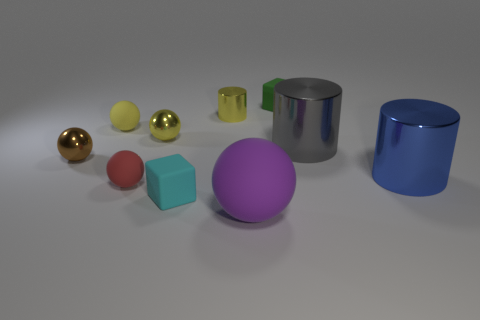Is the number of rubber balls that are in front of the yellow metallic sphere the same as the number of small cyan blocks that are on the left side of the small brown object?
Your response must be concise. No. What material is the cylinder on the left side of the matte block behind the big blue object?
Make the answer very short. Metal. What number of objects are either purple shiny blocks or tiny metallic spheres?
Give a very brief answer. 2. There is a metal ball that is the same color as the small cylinder; what is its size?
Provide a short and direct response. Small. Are there fewer small yellow metallic things than big blue metal cylinders?
Keep it short and to the point. No. The yellow thing that is made of the same material as the yellow cylinder is what size?
Keep it short and to the point. Small. How big is the brown metallic ball?
Keep it short and to the point. Small. What is the shape of the big purple rubber thing?
Your answer should be very brief. Sphere. There is a matte sphere that is behind the big blue shiny cylinder; is its color the same as the tiny cylinder?
Your answer should be compact. Yes. What size is the other thing that is the same shape as the tiny green matte object?
Provide a succinct answer. Small. 